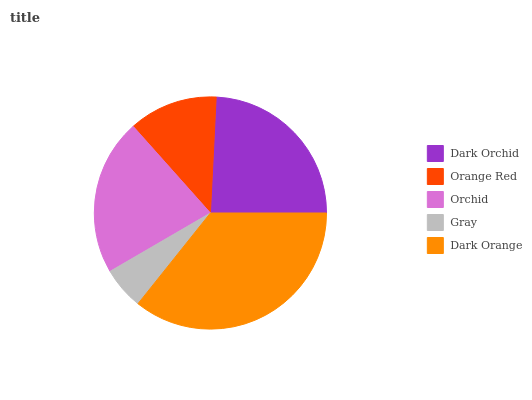Is Gray the minimum?
Answer yes or no. Yes. Is Dark Orange the maximum?
Answer yes or no. Yes. Is Orange Red the minimum?
Answer yes or no. No. Is Orange Red the maximum?
Answer yes or no. No. Is Dark Orchid greater than Orange Red?
Answer yes or no. Yes. Is Orange Red less than Dark Orchid?
Answer yes or no. Yes. Is Orange Red greater than Dark Orchid?
Answer yes or no. No. Is Dark Orchid less than Orange Red?
Answer yes or no. No. Is Orchid the high median?
Answer yes or no. Yes. Is Orchid the low median?
Answer yes or no. Yes. Is Orange Red the high median?
Answer yes or no. No. Is Gray the low median?
Answer yes or no. No. 